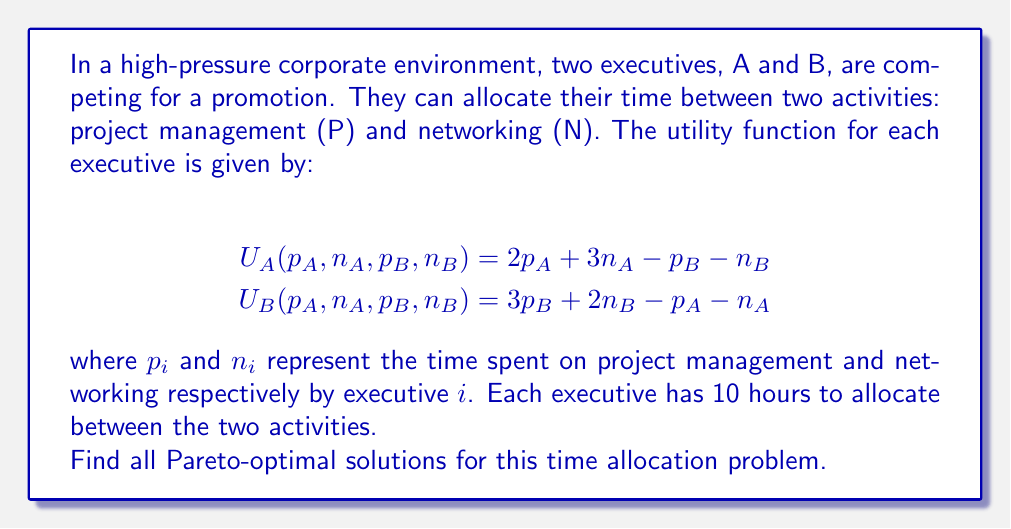Can you solve this math problem? To solve this game theory problem and find the Pareto-optimal solutions, we'll follow these steps:

1) First, let's define the constraints:
   $p_A + n_A = 10$
   $p_B + n_B = 10$

2) A solution is Pareto-optimal if there's no way to improve one executive's utility without decreasing the other's. To find these solutions, we'll maximize a weighted sum of utilities:

   $$\max_{\{p_A, n_A, p_B, n_B\}} \lambda U_A + (1-\lambda) U_B$$

   where $0 \leq \lambda \leq 1$

3) Substituting the utility functions:

   $$\max \lambda(2p_A + 3n_A - p_B - n_B) + (1-\lambda)(3p_B + 2n_B - p_A - n_A)$$

4) Simplifying:

   $$\max (3\lambda-1)p_A + (4\lambda-1)n_A + (2-3\lambda)p_B + (1-2\lambda)n_B$$

5) Using the constraints to eliminate $n_A$ and $n_B$:

   $$\max (3\lambda-1)p_A + (4\lambda-1)(10-p_A) + (2-3\lambda)p_B + (1-2\lambda)(10-p_B)$$

6) Simplifying:

   $$\max (-\lambda-1)p_A + (2-\lambda)p_B + \text{constant terms}$$

7) The optimal solution depends on the coefficients of $p_A$ and $p_B$:

   If $-\lambda-1 > 0$ and $2-\lambda > 0$, maximize $p_A$ and $p_B$
   If $-\lambda-1 > 0$ and $2-\lambda < 0$, maximize $p_A$, minimize $p_B$
   If $-\lambda-1 < 0$ and $2-\lambda > 0$, minimize $p_A$, maximize $p_B$
   If $-\lambda-1 < 0$ and $2-\lambda < 0$, minimize $p_A$ and $p_B$

8) Solving these inequalities:

   $-\lambda-1 > 0$ implies $\lambda < -1$ (impossible as $0 \leq \lambda \leq 1$)
   $2-\lambda > 0$ implies $\lambda < 2$ (always true for $0 \leq \lambda \leq 1$)

9) Therefore, for all values of $\lambda$, we should minimize $p_A$ and maximize $p_B$.

This means the Pareto-optimal solutions are:
$p_A = 0, n_A = 10, p_B = 10, n_B = 0$
Answer: The Pareto-optimal solution is:
$$(p_A, n_A, p_B, n_B) = (0, 10, 10, 0)$$
This means Executive A should spend all 10 hours on networking, while Executive B should spend all 10 hours on project management. 